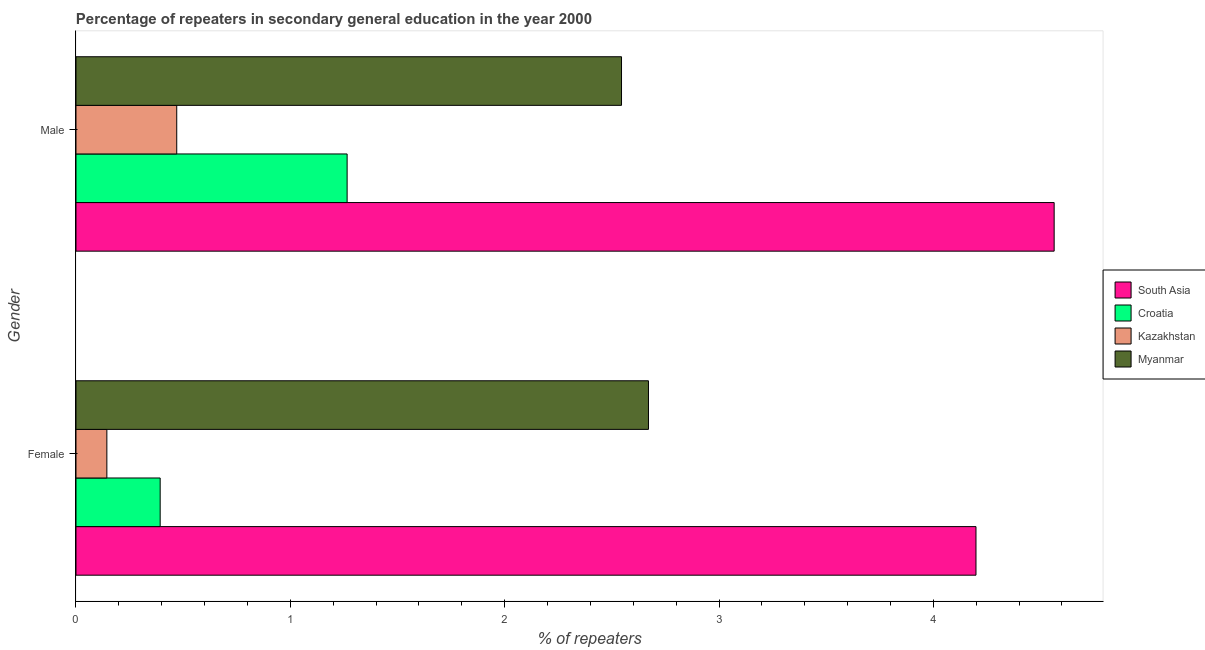How many groups of bars are there?
Provide a short and direct response. 2. Are the number of bars per tick equal to the number of legend labels?
Your answer should be very brief. Yes. Are the number of bars on each tick of the Y-axis equal?
Provide a succinct answer. Yes. How many bars are there on the 1st tick from the top?
Provide a short and direct response. 4. How many bars are there on the 1st tick from the bottom?
Your answer should be very brief. 4. What is the percentage of male repeaters in South Asia?
Offer a terse response. 4.56. Across all countries, what is the maximum percentage of female repeaters?
Offer a terse response. 4.2. Across all countries, what is the minimum percentage of female repeaters?
Provide a short and direct response. 0.14. In which country was the percentage of male repeaters minimum?
Your answer should be very brief. Kazakhstan. What is the total percentage of female repeaters in the graph?
Keep it short and to the point. 7.41. What is the difference between the percentage of female repeaters in Myanmar and that in Croatia?
Your response must be concise. 2.28. What is the difference between the percentage of female repeaters in Myanmar and the percentage of male repeaters in Kazakhstan?
Give a very brief answer. 2.2. What is the average percentage of male repeaters per country?
Offer a very short reply. 2.21. What is the difference between the percentage of female repeaters and percentage of male repeaters in South Asia?
Provide a succinct answer. -0.36. What is the ratio of the percentage of female repeaters in South Asia to that in Myanmar?
Your response must be concise. 1.57. Is the percentage of female repeaters in Myanmar less than that in Croatia?
Offer a terse response. No. In how many countries, is the percentage of female repeaters greater than the average percentage of female repeaters taken over all countries?
Your answer should be very brief. 2. What does the 1st bar from the top in Female represents?
Provide a short and direct response. Myanmar. What does the 4th bar from the bottom in Male represents?
Ensure brevity in your answer.  Myanmar. How many bars are there?
Your answer should be very brief. 8. How many countries are there in the graph?
Your response must be concise. 4. What is the difference between two consecutive major ticks on the X-axis?
Keep it short and to the point. 1. Are the values on the major ticks of X-axis written in scientific E-notation?
Your answer should be compact. No. Does the graph contain any zero values?
Your answer should be compact. No. What is the title of the graph?
Provide a short and direct response. Percentage of repeaters in secondary general education in the year 2000. Does "Haiti" appear as one of the legend labels in the graph?
Ensure brevity in your answer.  No. What is the label or title of the X-axis?
Provide a short and direct response. % of repeaters. What is the label or title of the Y-axis?
Offer a terse response. Gender. What is the % of repeaters of South Asia in Female?
Offer a very short reply. 4.2. What is the % of repeaters in Croatia in Female?
Give a very brief answer. 0.39. What is the % of repeaters of Kazakhstan in Female?
Ensure brevity in your answer.  0.14. What is the % of repeaters in Myanmar in Female?
Ensure brevity in your answer.  2.67. What is the % of repeaters in South Asia in Male?
Offer a very short reply. 4.56. What is the % of repeaters of Croatia in Male?
Give a very brief answer. 1.26. What is the % of repeaters in Kazakhstan in Male?
Provide a succinct answer. 0.47. What is the % of repeaters of Myanmar in Male?
Offer a terse response. 2.55. Across all Gender, what is the maximum % of repeaters in South Asia?
Keep it short and to the point. 4.56. Across all Gender, what is the maximum % of repeaters of Croatia?
Provide a succinct answer. 1.26. Across all Gender, what is the maximum % of repeaters of Kazakhstan?
Your response must be concise. 0.47. Across all Gender, what is the maximum % of repeaters in Myanmar?
Make the answer very short. 2.67. Across all Gender, what is the minimum % of repeaters in South Asia?
Give a very brief answer. 4.2. Across all Gender, what is the minimum % of repeaters in Croatia?
Give a very brief answer. 0.39. Across all Gender, what is the minimum % of repeaters in Kazakhstan?
Your response must be concise. 0.14. Across all Gender, what is the minimum % of repeaters in Myanmar?
Keep it short and to the point. 2.55. What is the total % of repeaters of South Asia in the graph?
Provide a short and direct response. 8.76. What is the total % of repeaters in Croatia in the graph?
Keep it short and to the point. 1.66. What is the total % of repeaters in Kazakhstan in the graph?
Make the answer very short. 0.61. What is the total % of repeaters in Myanmar in the graph?
Make the answer very short. 5.22. What is the difference between the % of repeaters of South Asia in Female and that in Male?
Keep it short and to the point. -0.36. What is the difference between the % of repeaters of Croatia in Female and that in Male?
Give a very brief answer. -0.87. What is the difference between the % of repeaters in Kazakhstan in Female and that in Male?
Your response must be concise. -0.33. What is the difference between the % of repeaters in Myanmar in Female and that in Male?
Provide a succinct answer. 0.13. What is the difference between the % of repeaters in South Asia in Female and the % of repeaters in Croatia in Male?
Provide a short and direct response. 2.93. What is the difference between the % of repeaters in South Asia in Female and the % of repeaters in Kazakhstan in Male?
Offer a very short reply. 3.73. What is the difference between the % of repeaters in South Asia in Female and the % of repeaters in Myanmar in Male?
Your response must be concise. 1.65. What is the difference between the % of repeaters of Croatia in Female and the % of repeaters of Kazakhstan in Male?
Keep it short and to the point. -0.08. What is the difference between the % of repeaters of Croatia in Female and the % of repeaters of Myanmar in Male?
Your answer should be compact. -2.15. What is the difference between the % of repeaters of Kazakhstan in Female and the % of repeaters of Myanmar in Male?
Offer a terse response. -2.4. What is the average % of repeaters of South Asia per Gender?
Your answer should be compact. 4.38. What is the average % of repeaters of Croatia per Gender?
Ensure brevity in your answer.  0.83. What is the average % of repeaters in Kazakhstan per Gender?
Keep it short and to the point. 0.31. What is the average % of repeaters of Myanmar per Gender?
Ensure brevity in your answer.  2.61. What is the difference between the % of repeaters of South Asia and % of repeaters of Croatia in Female?
Make the answer very short. 3.81. What is the difference between the % of repeaters of South Asia and % of repeaters of Kazakhstan in Female?
Provide a short and direct response. 4.05. What is the difference between the % of repeaters in South Asia and % of repeaters in Myanmar in Female?
Keep it short and to the point. 1.53. What is the difference between the % of repeaters in Croatia and % of repeaters in Kazakhstan in Female?
Provide a succinct answer. 0.25. What is the difference between the % of repeaters in Croatia and % of repeaters in Myanmar in Female?
Provide a succinct answer. -2.28. What is the difference between the % of repeaters of Kazakhstan and % of repeaters of Myanmar in Female?
Offer a terse response. -2.53. What is the difference between the % of repeaters in South Asia and % of repeaters in Croatia in Male?
Provide a succinct answer. 3.3. What is the difference between the % of repeaters of South Asia and % of repeaters of Kazakhstan in Male?
Give a very brief answer. 4.09. What is the difference between the % of repeaters in South Asia and % of repeaters in Myanmar in Male?
Keep it short and to the point. 2.02. What is the difference between the % of repeaters of Croatia and % of repeaters of Kazakhstan in Male?
Your response must be concise. 0.79. What is the difference between the % of repeaters in Croatia and % of repeaters in Myanmar in Male?
Ensure brevity in your answer.  -1.28. What is the difference between the % of repeaters of Kazakhstan and % of repeaters of Myanmar in Male?
Your answer should be very brief. -2.08. What is the ratio of the % of repeaters of South Asia in Female to that in Male?
Provide a short and direct response. 0.92. What is the ratio of the % of repeaters of Croatia in Female to that in Male?
Your answer should be compact. 0.31. What is the ratio of the % of repeaters of Kazakhstan in Female to that in Male?
Give a very brief answer. 0.31. What is the ratio of the % of repeaters in Myanmar in Female to that in Male?
Provide a succinct answer. 1.05. What is the difference between the highest and the second highest % of repeaters in South Asia?
Provide a succinct answer. 0.36. What is the difference between the highest and the second highest % of repeaters of Croatia?
Your answer should be compact. 0.87. What is the difference between the highest and the second highest % of repeaters of Kazakhstan?
Offer a very short reply. 0.33. What is the difference between the highest and the second highest % of repeaters of Myanmar?
Your answer should be compact. 0.13. What is the difference between the highest and the lowest % of repeaters in South Asia?
Give a very brief answer. 0.36. What is the difference between the highest and the lowest % of repeaters in Croatia?
Keep it short and to the point. 0.87. What is the difference between the highest and the lowest % of repeaters of Kazakhstan?
Provide a short and direct response. 0.33. What is the difference between the highest and the lowest % of repeaters of Myanmar?
Your response must be concise. 0.13. 